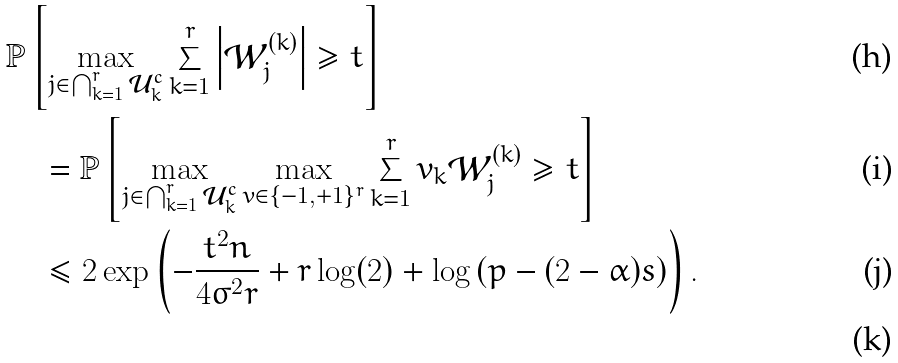Convert formula to latex. <formula><loc_0><loc_0><loc_500><loc_500>& \mathbb { P } \left [ \max _ { j \in \bigcap _ { k = 1 } ^ { r } \mathcal { U } _ { k } ^ { c } } \sum _ { k = 1 } ^ { r } \left | \mathcal { W } _ { j } ^ { ( k ) } \right | \geq t \right ] \\ & \quad = \mathbb { P } \left [ \max _ { j \in \bigcap _ { k = 1 } ^ { r } \mathcal { U } _ { k } ^ { c } } \max _ { v \in \{ - 1 , + 1 \} ^ { r } } \sum _ { k = 1 } ^ { r } v _ { k } \mathcal { W } _ { j } ^ { ( k ) } \geq t \right ] \\ & \quad \leq 2 \exp \left ( - \frac { t ^ { 2 } n } { 4 \sigma ^ { 2 } r } + r \log ( 2 ) + \log \left ( p - ( 2 - \alpha ) s \right ) \right ) . \\</formula> 